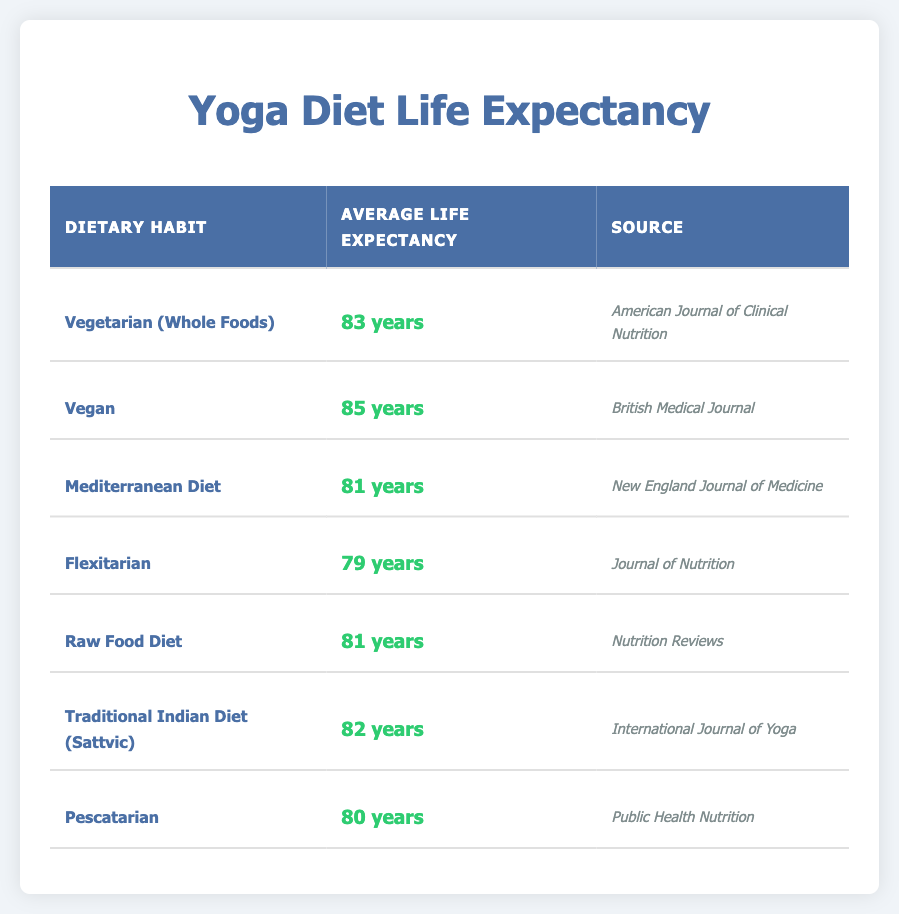What is the average life expectancy for individuals following a Vegan diet? According to the table, the average life expectancy for individuals following a Vegan diet is listed directly as 85 years.
Answer: 85 years Which dietary habit has the highest life expectancy? By examining the average life expectancy figures in the table, we see that the Vegan diet has the highest value of 85 years.
Answer: Vegan diet Is the average life expectancy for a Pescatarian higher than that for a Mediterranean diet? In the table, the average life expectancy for Pescatarian is 80 years, while for Mediterranean diet, it is 81 years. Since 80 is not higher than 81, the answer is no.
Answer: No Calculate the difference in average life expectancy between those who are Vegan and those who follow a Flexitarian diet. The average life expectancy for Vegan is 85 years and for Flexitarian is 79 years. The difference is 85 - 79 = 6 years.
Answer: 6 years What is the average life expectancy for the Traditional Indian Diet (Sattvic) compared to the Raw Food Diet? The average life expectancy for Traditional Indian Diet (Sattvic) is 82 years, while for Raw Food Diet it is 81 years. Therefore, Sattvic has a higher average life expectancy by 1 year.
Answer: 1 year True or False: Individuals on the Raw Food Diet have the highest average life expectancy among all dietary habits listed. The highest average life expectancy in the table is for the Vegan diet at 85 years, and the Raw Food Diet has an average of 81 years, therefore the statement is false.
Answer: False Calculate the average life expectancy of individuals following the Vegetarian (Whole Foods) and Traditional Indian Diet (Sattvic). The life expectancy for Vegetarian (Whole Foods) is 83 years and for Traditional Indian Diet (Sattvic) it is 82 years. Adding these gives 83 + 82 = 165 years, and dividing by the two diets gives an average of 165 / 2 = 82.5 years.
Answer: 82.5 years 